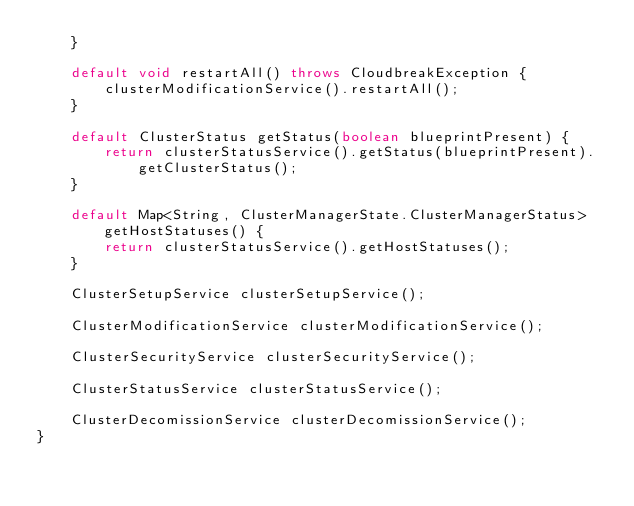<code> <loc_0><loc_0><loc_500><loc_500><_Java_>    }

    default void restartAll() throws CloudbreakException {
        clusterModificationService().restartAll();
    }

    default ClusterStatus getStatus(boolean blueprintPresent) {
        return clusterStatusService().getStatus(blueprintPresent).getClusterStatus();
    }

    default Map<String, ClusterManagerState.ClusterManagerStatus> getHostStatuses() {
        return clusterStatusService().getHostStatuses();
    }

    ClusterSetupService clusterSetupService();

    ClusterModificationService clusterModificationService();

    ClusterSecurityService clusterSecurityService();

    ClusterStatusService clusterStatusService();

    ClusterDecomissionService clusterDecomissionService();
}
</code> 